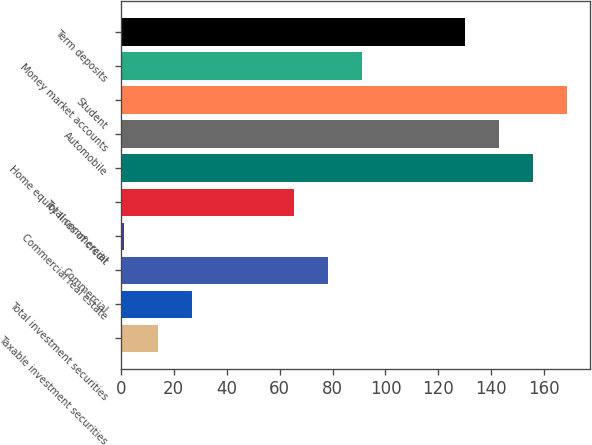Convert chart. <chart><loc_0><loc_0><loc_500><loc_500><bar_chart><fcel>Taxable investment securities<fcel>Total investment securities<fcel>Commercial<fcel>Commercial real estate<fcel>Total commercial<fcel>Home equity lines of credit<fcel>Automobile<fcel>Student<fcel>Money market accounts<fcel>Term deposits<nl><fcel>13.9<fcel>26.8<fcel>78.4<fcel>1<fcel>65.5<fcel>155.8<fcel>142.9<fcel>168.7<fcel>91.3<fcel>130<nl></chart> 